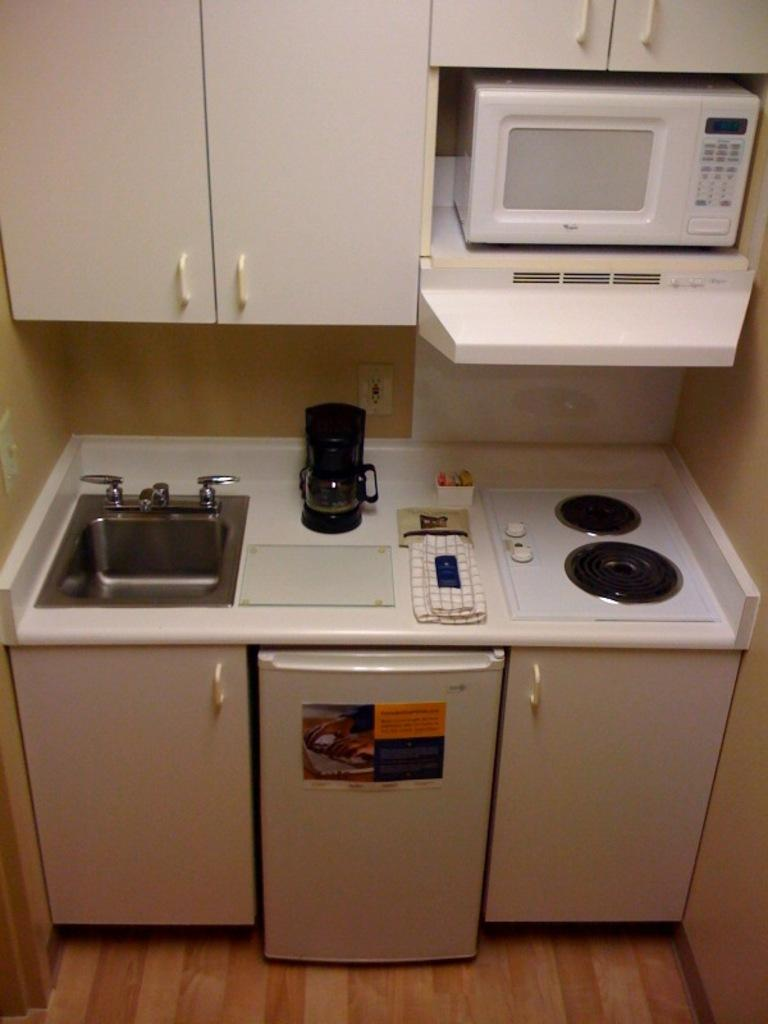What type of appliance can be seen in the image? There is a stove in the image. What is another appliance that can be seen in the image? There is an oven in the image. What feature is present near the stove and oven? There is a sink in the image. What can be used to control the flow of water in the sink? There are taps in the image. What type of storage is present in the image? There are white color cupboards in the image. What surface can be seen in the image? There are objects on a white color surface in the image. How many soldiers are present in the image? There are no soldiers or army-related elements present in the image. What type of crowd can be seen in the image? There is no crowd present in the image; it features kitchen appliances and fixtures. 